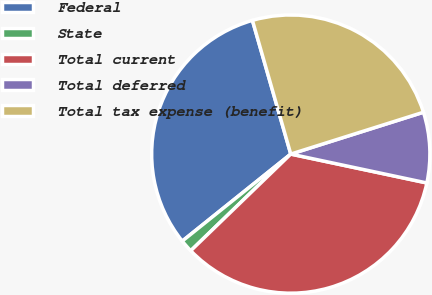Convert chart. <chart><loc_0><loc_0><loc_500><loc_500><pie_chart><fcel>Federal<fcel>State<fcel>Total current<fcel>Total deferred<fcel>Total tax expense (benefit)<nl><fcel>31.31%<fcel>1.47%<fcel>34.44%<fcel>8.19%<fcel>24.58%<nl></chart> 